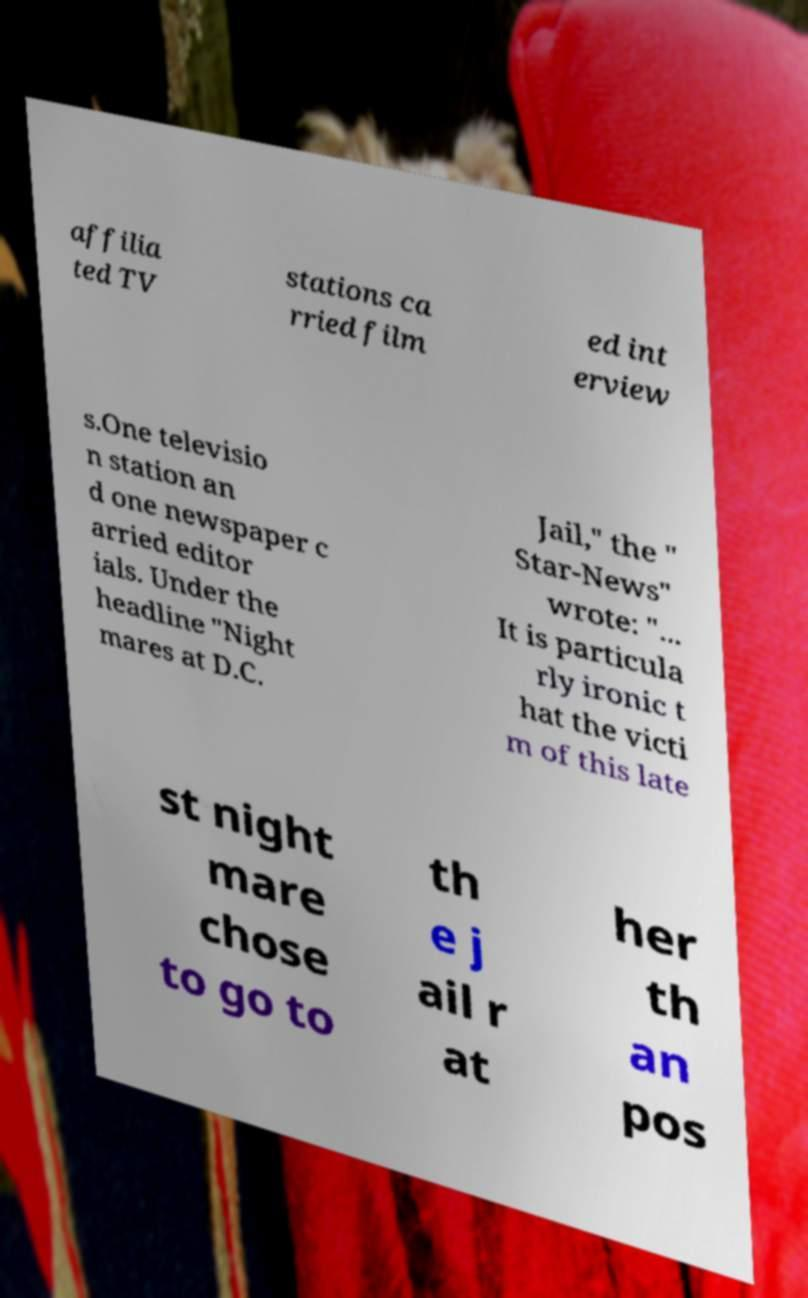Could you extract and type out the text from this image? affilia ted TV stations ca rried film ed int erview s.One televisio n station an d one newspaper c arried editor ials. Under the headline "Night mares at D.C. Jail," the " Star-News" wrote: "... It is particula rly ironic t hat the victi m of this late st night mare chose to go to th e j ail r at her th an pos 